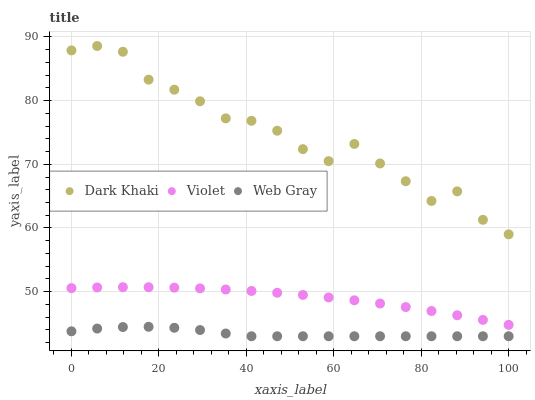Does Web Gray have the minimum area under the curve?
Answer yes or no. Yes. Does Dark Khaki have the maximum area under the curve?
Answer yes or no. Yes. Does Violet have the minimum area under the curve?
Answer yes or no. No. Does Violet have the maximum area under the curve?
Answer yes or no. No. Is Violet the smoothest?
Answer yes or no. Yes. Is Dark Khaki the roughest?
Answer yes or no. Yes. Is Web Gray the smoothest?
Answer yes or no. No. Is Web Gray the roughest?
Answer yes or no. No. Does Web Gray have the lowest value?
Answer yes or no. Yes. Does Violet have the lowest value?
Answer yes or no. No. Does Dark Khaki have the highest value?
Answer yes or no. Yes. Does Violet have the highest value?
Answer yes or no. No. Is Violet less than Dark Khaki?
Answer yes or no. Yes. Is Violet greater than Web Gray?
Answer yes or no. Yes. Does Violet intersect Dark Khaki?
Answer yes or no. No. 